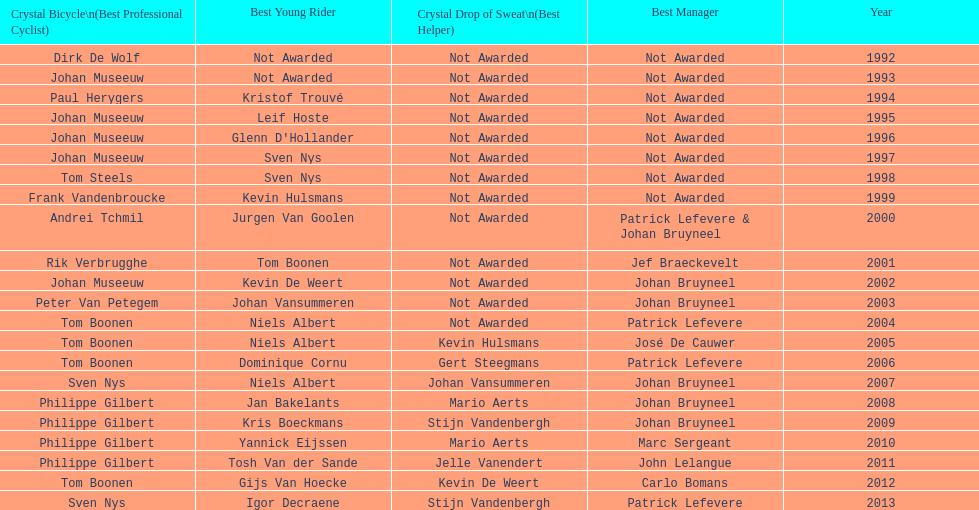What is the median number of times johan museeuw participated? 5. Can you parse all the data within this table? {'header': ['Crystal Bicycle\\n(Best Professional Cyclist)', 'Best Young Rider', 'Crystal Drop of Sweat\\n(Best Helper)', 'Best Manager', 'Year'], 'rows': [['Dirk De Wolf', 'Not Awarded', 'Not Awarded', 'Not Awarded', '1992'], ['Johan Museeuw', 'Not Awarded', 'Not Awarded', 'Not Awarded', '1993'], ['Paul Herygers', 'Kristof Trouvé', 'Not Awarded', 'Not Awarded', '1994'], ['Johan Museeuw', 'Leif Hoste', 'Not Awarded', 'Not Awarded', '1995'], ['Johan Museeuw', "Glenn D'Hollander", 'Not Awarded', 'Not Awarded', '1996'], ['Johan Museeuw', 'Sven Nys', 'Not Awarded', 'Not Awarded', '1997'], ['Tom Steels', 'Sven Nys', 'Not Awarded', 'Not Awarded', '1998'], ['Frank Vandenbroucke', 'Kevin Hulsmans', 'Not Awarded', 'Not Awarded', '1999'], ['Andrei Tchmil', 'Jurgen Van Goolen', 'Not Awarded', 'Patrick Lefevere & Johan Bruyneel', '2000'], ['Rik Verbrugghe', 'Tom Boonen', 'Not Awarded', 'Jef Braeckevelt', '2001'], ['Johan Museeuw', 'Kevin De Weert', 'Not Awarded', 'Johan Bruyneel', '2002'], ['Peter Van Petegem', 'Johan Vansummeren', 'Not Awarded', 'Johan Bruyneel', '2003'], ['Tom Boonen', 'Niels Albert', 'Not Awarded', 'Patrick Lefevere', '2004'], ['Tom Boonen', 'Niels Albert', 'Kevin Hulsmans', 'José De Cauwer', '2005'], ['Tom Boonen', 'Dominique Cornu', 'Gert Steegmans', 'Patrick Lefevere', '2006'], ['Sven Nys', 'Niels Albert', 'Johan Vansummeren', 'Johan Bruyneel', '2007'], ['Philippe Gilbert', 'Jan Bakelants', 'Mario Aerts', 'Johan Bruyneel', '2008'], ['Philippe Gilbert', 'Kris Boeckmans', 'Stijn Vandenbergh', 'Johan Bruyneel', '2009'], ['Philippe Gilbert', 'Yannick Eijssen', 'Mario Aerts', 'Marc Sergeant', '2010'], ['Philippe Gilbert', 'Tosh Van der Sande', 'Jelle Vanendert', 'John Lelangue', '2011'], ['Tom Boonen', 'Gijs Van Hoecke', 'Kevin De Weert', 'Carlo Bomans', '2012'], ['Sven Nys', 'Igor Decraene', 'Stijn Vandenbergh', 'Patrick Lefevere', '2013']]} 